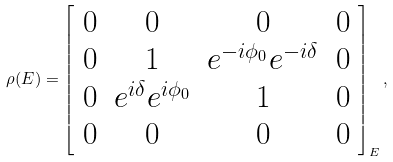Convert formula to latex. <formula><loc_0><loc_0><loc_500><loc_500>\rho ( E ) = \left [ \begin{array} { c c c c } 0 & 0 & 0 & 0 \\ 0 & 1 & e ^ { - i \phi _ { 0 } } e ^ { - i \delta } & 0 \\ 0 & e ^ { i \delta } e ^ { i \phi _ { 0 } } & 1 & 0 \\ 0 & 0 & 0 & 0 \end{array} \right ] _ { E } ,</formula> 